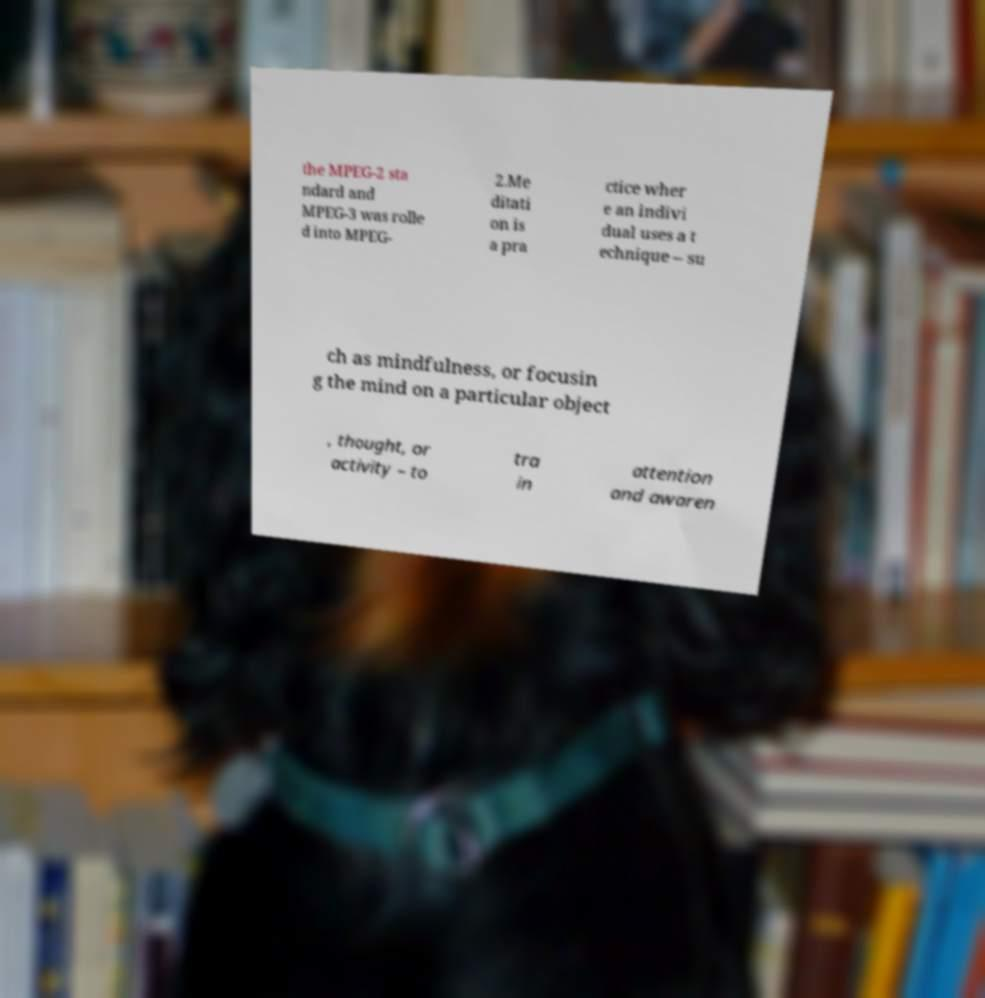Could you extract and type out the text from this image? the MPEG-2 sta ndard and MPEG-3 was rolle d into MPEG- 2.Me ditati on is a pra ctice wher e an indivi dual uses a t echnique – su ch as mindfulness, or focusin g the mind on a particular object , thought, or activity – to tra in attention and awaren 